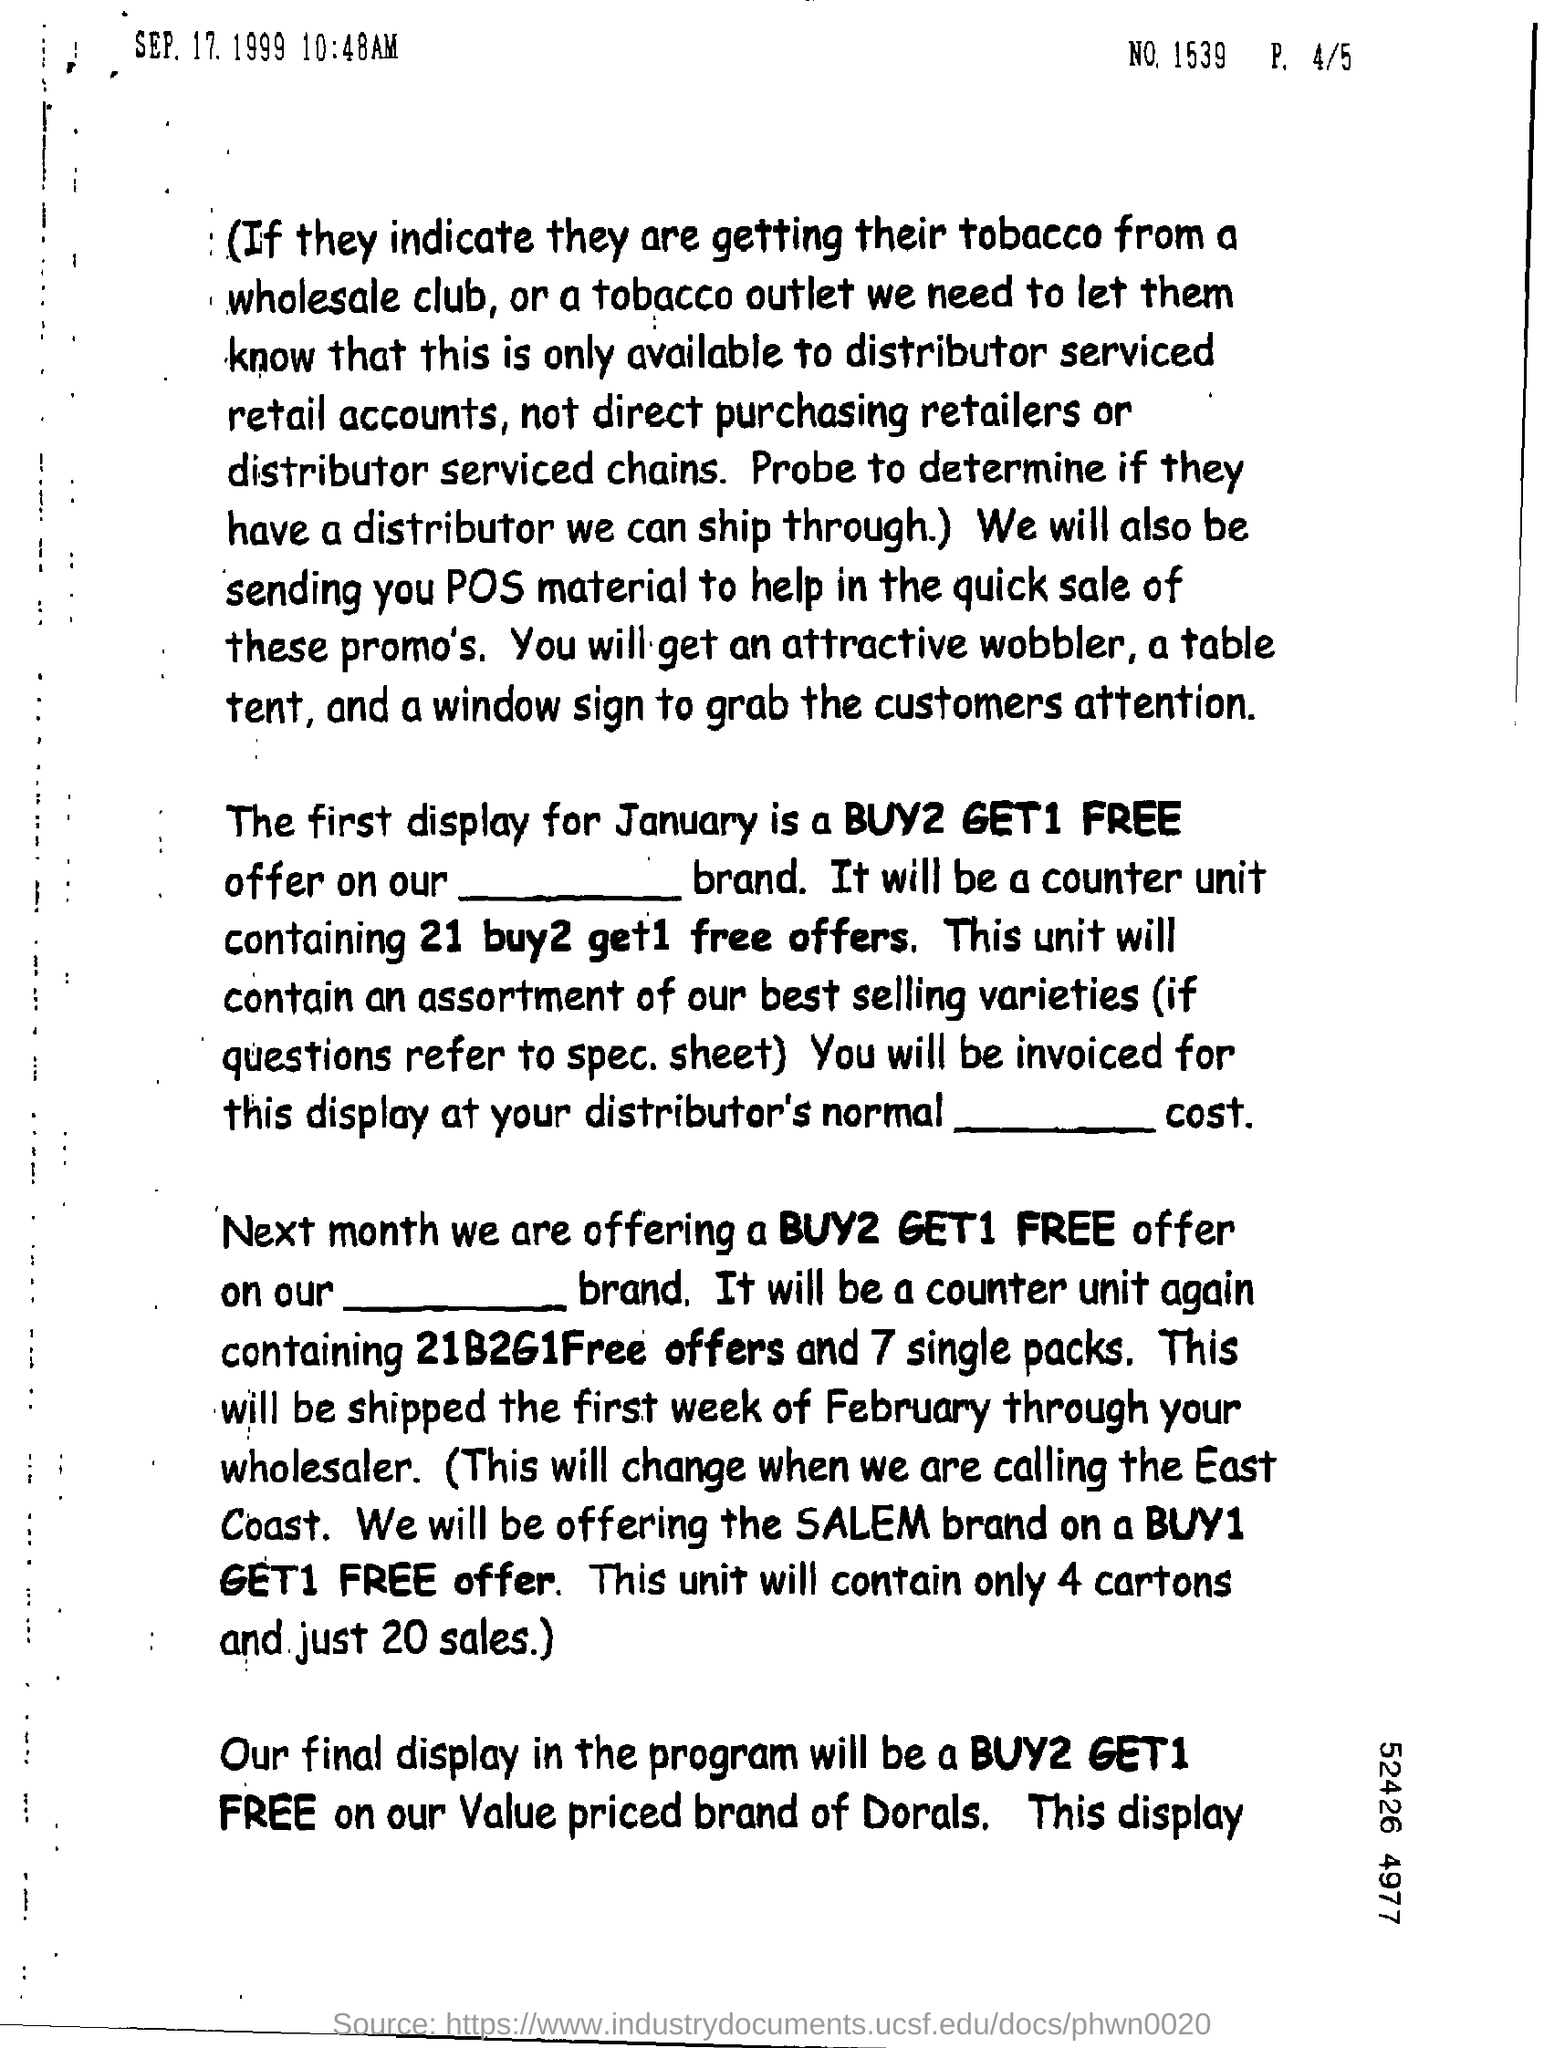Mention a couple of crucial points in this snapshot. The final display in the program will be "BUY2 GET1 FREE.". 